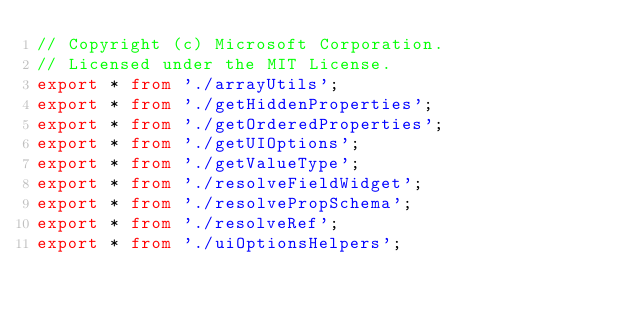Convert code to text. <code><loc_0><loc_0><loc_500><loc_500><_TypeScript_>// Copyright (c) Microsoft Corporation.
// Licensed under the MIT License.
export * from './arrayUtils';
export * from './getHiddenProperties';
export * from './getOrderedProperties';
export * from './getUIOptions';
export * from './getValueType';
export * from './resolveFieldWidget';
export * from './resolvePropSchema';
export * from './resolveRef';
export * from './uiOptionsHelpers';
</code> 